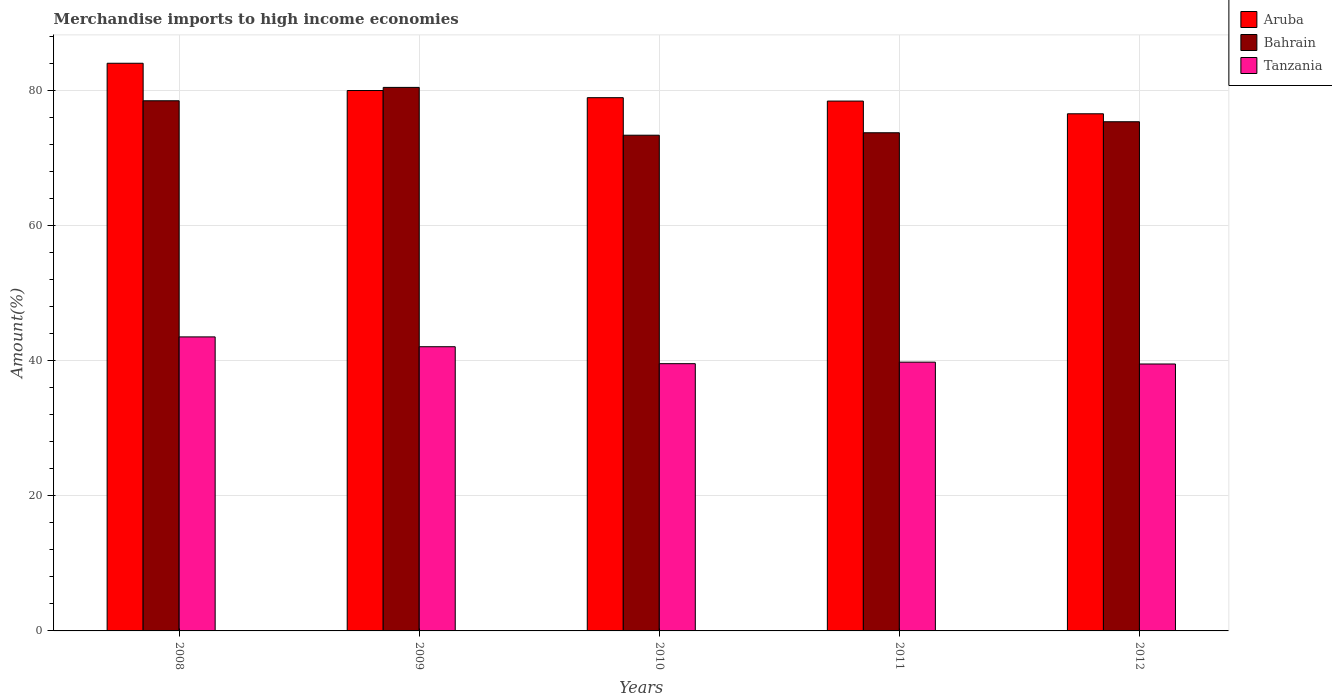How many different coloured bars are there?
Provide a short and direct response. 3. How many groups of bars are there?
Your response must be concise. 5. Are the number of bars on each tick of the X-axis equal?
Give a very brief answer. Yes. What is the label of the 5th group of bars from the left?
Give a very brief answer. 2012. What is the percentage of amount earned from merchandise imports in Aruba in 2011?
Your response must be concise. 78.49. Across all years, what is the maximum percentage of amount earned from merchandise imports in Tanzania?
Ensure brevity in your answer.  43.55. Across all years, what is the minimum percentage of amount earned from merchandise imports in Aruba?
Your answer should be very brief. 76.6. In which year was the percentage of amount earned from merchandise imports in Bahrain maximum?
Keep it short and to the point. 2009. What is the total percentage of amount earned from merchandise imports in Aruba in the graph?
Offer a very short reply. 398.22. What is the difference between the percentage of amount earned from merchandise imports in Tanzania in 2008 and that in 2009?
Provide a succinct answer. 1.45. What is the difference between the percentage of amount earned from merchandise imports in Aruba in 2010 and the percentage of amount earned from merchandise imports in Bahrain in 2012?
Your answer should be compact. 3.57. What is the average percentage of amount earned from merchandise imports in Tanzania per year?
Offer a very short reply. 40.92. In the year 2010, what is the difference between the percentage of amount earned from merchandise imports in Aruba and percentage of amount earned from merchandise imports in Bahrain?
Keep it short and to the point. 5.56. What is the ratio of the percentage of amount earned from merchandise imports in Aruba in 2009 to that in 2012?
Provide a short and direct response. 1.04. Is the percentage of amount earned from merchandise imports in Tanzania in 2010 less than that in 2012?
Provide a succinct answer. No. Is the difference between the percentage of amount earned from merchandise imports in Aruba in 2009 and 2011 greater than the difference between the percentage of amount earned from merchandise imports in Bahrain in 2009 and 2011?
Provide a short and direct response. No. What is the difference between the highest and the second highest percentage of amount earned from merchandise imports in Aruba?
Provide a succinct answer. 4.04. What is the difference between the highest and the lowest percentage of amount earned from merchandise imports in Tanzania?
Your response must be concise. 4.01. In how many years, is the percentage of amount earned from merchandise imports in Aruba greater than the average percentage of amount earned from merchandise imports in Aruba taken over all years?
Make the answer very short. 2. Is the sum of the percentage of amount earned from merchandise imports in Aruba in 2009 and 2012 greater than the maximum percentage of amount earned from merchandise imports in Bahrain across all years?
Your answer should be compact. Yes. What does the 3rd bar from the left in 2011 represents?
Make the answer very short. Tanzania. What does the 3rd bar from the right in 2009 represents?
Give a very brief answer. Aruba. Does the graph contain any zero values?
Provide a short and direct response. No. How are the legend labels stacked?
Offer a very short reply. Vertical. What is the title of the graph?
Offer a terse response. Merchandise imports to high income economies. Does "Moldova" appear as one of the legend labels in the graph?
Ensure brevity in your answer.  No. What is the label or title of the X-axis?
Make the answer very short. Years. What is the label or title of the Y-axis?
Provide a succinct answer. Amount(%). What is the Amount(%) in Aruba in 2008?
Your answer should be compact. 84.09. What is the Amount(%) in Bahrain in 2008?
Provide a succinct answer. 78.53. What is the Amount(%) of Tanzania in 2008?
Offer a very short reply. 43.55. What is the Amount(%) in Aruba in 2009?
Make the answer very short. 80.05. What is the Amount(%) in Bahrain in 2009?
Your answer should be compact. 80.51. What is the Amount(%) in Tanzania in 2009?
Your answer should be very brief. 42.1. What is the Amount(%) in Aruba in 2010?
Keep it short and to the point. 78.99. What is the Amount(%) in Bahrain in 2010?
Ensure brevity in your answer.  73.43. What is the Amount(%) of Tanzania in 2010?
Keep it short and to the point. 39.59. What is the Amount(%) of Aruba in 2011?
Give a very brief answer. 78.49. What is the Amount(%) in Bahrain in 2011?
Your answer should be compact. 73.79. What is the Amount(%) of Tanzania in 2011?
Make the answer very short. 39.81. What is the Amount(%) in Aruba in 2012?
Keep it short and to the point. 76.6. What is the Amount(%) of Bahrain in 2012?
Offer a very short reply. 75.42. What is the Amount(%) of Tanzania in 2012?
Provide a short and direct response. 39.54. Across all years, what is the maximum Amount(%) of Aruba?
Make the answer very short. 84.09. Across all years, what is the maximum Amount(%) of Bahrain?
Give a very brief answer. 80.51. Across all years, what is the maximum Amount(%) in Tanzania?
Offer a terse response. 43.55. Across all years, what is the minimum Amount(%) of Aruba?
Give a very brief answer. 76.6. Across all years, what is the minimum Amount(%) in Bahrain?
Offer a very short reply. 73.43. Across all years, what is the minimum Amount(%) of Tanzania?
Offer a very short reply. 39.54. What is the total Amount(%) of Aruba in the graph?
Provide a short and direct response. 398.22. What is the total Amount(%) in Bahrain in the graph?
Keep it short and to the point. 381.69. What is the total Amount(%) in Tanzania in the graph?
Keep it short and to the point. 204.59. What is the difference between the Amount(%) of Aruba in 2008 and that in 2009?
Provide a succinct answer. 4.04. What is the difference between the Amount(%) of Bahrain in 2008 and that in 2009?
Ensure brevity in your answer.  -1.98. What is the difference between the Amount(%) in Tanzania in 2008 and that in 2009?
Keep it short and to the point. 1.45. What is the difference between the Amount(%) in Aruba in 2008 and that in 2010?
Provide a short and direct response. 5.1. What is the difference between the Amount(%) in Bahrain in 2008 and that in 2010?
Your response must be concise. 5.1. What is the difference between the Amount(%) in Tanzania in 2008 and that in 2010?
Make the answer very short. 3.97. What is the difference between the Amount(%) of Aruba in 2008 and that in 2011?
Make the answer very short. 5.6. What is the difference between the Amount(%) in Bahrain in 2008 and that in 2011?
Your answer should be very brief. 4.74. What is the difference between the Amount(%) in Tanzania in 2008 and that in 2011?
Your answer should be compact. 3.74. What is the difference between the Amount(%) of Aruba in 2008 and that in 2012?
Your answer should be compact. 7.48. What is the difference between the Amount(%) of Bahrain in 2008 and that in 2012?
Ensure brevity in your answer.  3.11. What is the difference between the Amount(%) in Tanzania in 2008 and that in 2012?
Offer a very short reply. 4.01. What is the difference between the Amount(%) of Aruba in 2009 and that in 2010?
Provide a short and direct response. 1.06. What is the difference between the Amount(%) in Bahrain in 2009 and that in 2010?
Your answer should be very brief. 7.08. What is the difference between the Amount(%) in Tanzania in 2009 and that in 2010?
Provide a succinct answer. 2.51. What is the difference between the Amount(%) of Aruba in 2009 and that in 2011?
Provide a succinct answer. 1.56. What is the difference between the Amount(%) in Bahrain in 2009 and that in 2011?
Offer a terse response. 6.72. What is the difference between the Amount(%) in Tanzania in 2009 and that in 2011?
Provide a short and direct response. 2.29. What is the difference between the Amount(%) of Aruba in 2009 and that in 2012?
Ensure brevity in your answer.  3.45. What is the difference between the Amount(%) in Bahrain in 2009 and that in 2012?
Your answer should be very brief. 5.09. What is the difference between the Amount(%) of Tanzania in 2009 and that in 2012?
Offer a very short reply. 2.56. What is the difference between the Amount(%) in Aruba in 2010 and that in 2011?
Your answer should be very brief. 0.5. What is the difference between the Amount(%) of Bahrain in 2010 and that in 2011?
Offer a very short reply. -0.36. What is the difference between the Amount(%) of Tanzania in 2010 and that in 2011?
Your answer should be compact. -0.23. What is the difference between the Amount(%) in Aruba in 2010 and that in 2012?
Provide a succinct answer. 2.39. What is the difference between the Amount(%) in Bahrain in 2010 and that in 2012?
Provide a short and direct response. -1.99. What is the difference between the Amount(%) in Tanzania in 2010 and that in 2012?
Your answer should be very brief. 0.05. What is the difference between the Amount(%) of Aruba in 2011 and that in 2012?
Make the answer very short. 1.88. What is the difference between the Amount(%) in Bahrain in 2011 and that in 2012?
Give a very brief answer. -1.63. What is the difference between the Amount(%) of Tanzania in 2011 and that in 2012?
Your answer should be compact. 0.27. What is the difference between the Amount(%) in Aruba in 2008 and the Amount(%) in Bahrain in 2009?
Your answer should be very brief. 3.57. What is the difference between the Amount(%) of Aruba in 2008 and the Amount(%) of Tanzania in 2009?
Make the answer very short. 41.99. What is the difference between the Amount(%) in Bahrain in 2008 and the Amount(%) in Tanzania in 2009?
Your answer should be compact. 36.43. What is the difference between the Amount(%) in Aruba in 2008 and the Amount(%) in Bahrain in 2010?
Keep it short and to the point. 10.66. What is the difference between the Amount(%) of Aruba in 2008 and the Amount(%) of Tanzania in 2010?
Your answer should be compact. 44.5. What is the difference between the Amount(%) of Bahrain in 2008 and the Amount(%) of Tanzania in 2010?
Provide a succinct answer. 38.94. What is the difference between the Amount(%) of Aruba in 2008 and the Amount(%) of Bahrain in 2011?
Keep it short and to the point. 10.29. What is the difference between the Amount(%) in Aruba in 2008 and the Amount(%) in Tanzania in 2011?
Your answer should be very brief. 44.27. What is the difference between the Amount(%) of Bahrain in 2008 and the Amount(%) of Tanzania in 2011?
Your response must be concise. 38.72. What is the difference between the Amount(%) in Aruba in 2008 and the Amount(%) in Bahrain in 2012?
Offer a terse response. 8.66. What is the difference between the Amount(%) in Aruba in 2008 and the Amount(%) in Tanzania in 2012?
Provide a succinct answer. 44.55. What is the difference between the Amount(%) in Bahrain in 2008 and the Amount(%) in Tanzania in 2012?
Your answer should be compact. 38.99. What is the difference between the Amount(%) of Aruba in 2009 and the Amount(%) of Bahrain in 2010?
Your answer should be compact. 6.62. What is the difference between the Amount(%) of Aruba in 2009 and the Amount(%) of Tanzania in 2010?
Provide a succinct answer. 40.46. What is the difference between the Amount(%) of Bahrain in 2009 and the Amount(%) of Tanzania in 2010?
Give a very brief answer. 40.93. What is the difference between the Amount(%) in Aruba in 2009 and the Amount(%) in Bahrain in 2011?
Provide a succinct answer. 6.26. What is the difference between the Amount(%) in Aruba in 2009 and the Amount(%) in Tanzania in 2011?
Your response must be concise. 40.24. What is the difference between the Amount(%) of Bahrain in 2009 and the Amount(%) of Tanzania in 2011?
Provide a short and direct response. 40.7. What is the difference between the Amount(%) of Aruba in 2009 and the Amount(%) of Bahrain in 2012?
Ensure brevity in your answer.  4.63. What is the difference between the Amount(%) in Aruba in 2009 and the Amount(%) in Tanzania in 2012?
Ensure brevity in your answer.  40.51. What is the difference between the Amount(%) of Bahrain in 2009 and the Amount(%) of Tanzania in 2012?
Your answer should be very brief. 40.97. What is the difference between the Amount(%) of Aruba in 2010 and the Amount(%) of Bahrain in 2011?
Offer a terse response. 5.2. What is the difference between the Amount(%) of Aruba in 2010 and the Amount(%) of Tanzania in 2011?
Keep it short and to the point. 39.18. What is the difference between the Amount(%) of Bahrain in 2010 and the Amount(%) of Tanzania in 2011?
Provide a short and direct response. 33.62. What is the difference between the Amount(%) of Aruba in 2010 and the Amount(%) of Bahrain in 2012?
Your response must be concise. 3.57. What is the difference between the Amount(%) of Aruba in 2010 and the Amount(%) of Tanzania in 2012?
Offer a terse response. 39.45. What is the difference between the Amount(%) in Bahrain in 2010 and the Amount(%) in Tanzania in 2012?
Your response must be concise. 33.89. What is the difference between the Amount(%) in Aruba in 2011 and the Amount(%) in Bahrain in 2012?
Offer a very short reply. 3.06. What is the difference between the Amount(%) in Aruba in 2011 and the Amount(%) in Tanzania in 2012?
Your response must be concise. 38.95. What is the difference between the Amount(%) of Bahrain in 2011 and the Amount(%) of Tanzania in 2012?
Your answer should be very brief. 34.25. What is the average Amount(%) in Aruba per year?
Your answer should be very brief. 79.64. What is the average Amount(%) in Bahrain per year?
Provide a succinct answer. 76.34. What is the average Amount(%) in Tanzania per year?
Make the answer very short. 40.92. In the year 2008, what is the difference between the Amount(%) of Aruba and Amount(%) of Bahrain?
Provide a short and direct response. 5.56. In the year 2008, what is the difference between the Amount(%) in Aruba and Amount(%) in Tanzania?
Offer a terse response. 40.53. In the year 2008, what is the difference between the Amount(%) in Bahrain and Amount(%) in Tanzania?
Give a very brief answer. 34.98. In the year 2009, what is the difference between the Amount(%) in Aruba and Amount(%) in Bahrain?
Offer a very short reply. -0.46. In the year 2009, what is the difference between the Amount(%) of Aruba and Amount(%) of Tanzania?
Keep it short and to the point. 37.95. In the year 2009, what is the difference between the Amount(%) of Bahrain and Amount(%) of Tanzania?
Offer a very short reply. 38.41. In the year 2010, what is the difference between the Amount(%) in Aruba and Amount(%) in Bahrain?
Provide a succinct answer. 5.56. In the year 2010, what is the difference between the Amount(%) of Aruba and Amount(%) of Tanzania?
Offer a terse response. 39.4. In the year 2010, what is the difference between the Amount(%) of Bahrain and Amount(%) of Tanzania?
Your response must be concise. 33.84. In the year 2011, what is the difference between the Amount(%) of Aruba and Amount(%) of Bahrain?
Provide a short and direct response. 4.69. In the year 2011, what is the difference between the Amount(%) of Aruba and Amount(%) of Tanzania?
Ensure brevity in your answer.  38.67. In the year 2011, what is the difference between the Amount(%) of Bahrain and Amount(%) of Tanzania?
Make the answer very short. 33.98. In the year 2012, what is the difference between the Amount(%) in Aruba and Amount(%) in Bahrain?
Your answer should be compact. 1.18. In the year 2012, what is the difference between the Amount(%) of Aruba and Amount(%) of Tanzania?
Your response must be concise. 37.06. In the year 2012, what is the difference between the Amount(%) in Bahrain and Amount(%) in Tanzania?
Give a very brief answer. 35.88. What is the ratio of the Amount(%) in Aruba in 2008 to that in 2009?
Your answer should be compact. 1.05. What is the ratio of the Amount(%) of Bahrain in 2008 to that in 2009?
Provide a succinct answer. 0.98. What is the ratio of the Amount(%) in Tanzania in 2008 to that in 2009?
Ensure brevity in your answer.  1.03. What is the ratio of the Amount(%) in Aruba in 2008 to that in 2010?
Provide a short and direct response. 1.06. What is the ratio of the Amount(%) in Bahrain in 2008 to that in 2010?
Give a very brief answer. 1.07. What is the ratio of the Amount(%) of Tanzania in 2008 to that in 2010?
Your answer should be very brief. 1.1. What is the ratio of the Amount(%) of Aruba in 2008 to that in 2011?
Your response must be concise. 1.07. What is the ratio of the Amount(%) of Bahrain in 2008 to that in 2011?
Your answer should be very brief. 1.06. What is the ratio of the Amount(%) of Tanzania in 2008 to that in 2011?
Provide a short and direct response. 1.09. What is the ratio of the Amount(%) of Aruba in 2008 to that in 2012?
Keep it short and to the point. 1.1. What is the ratio of the Amount(%) in Bahrain in 2008 to that in 2012?
Your answer should be compact. 1.04. What is the ratio of the Amount(%) of Tanzania in 2008 to that in 2012?
Offer a terse response. 1.1. What is the ratio of the Amount(%) in Aruba in 2009 to that in 2010?
Your answer should be very brief. 1.01. What is the ratio of the Amount(%) of Bahrain in 2009 to that in 2010?
Make the answer very short. 1.1. What is the ratio of the Amount(%) of Tanzania in 2009 to that in 2010?
Give a very brief answer. 1.06. What is the ratio of the Amount(%) in Aruba in 2009 to that in 2011?
Offer a very short reply. 1.02. What is the ratio of the Amount(%) of Bahrain in 2009 to that in 2011?
Your answer should be very brief. 1.09. What is the ratio of the Amount(%) of Tanzania in 2009 to that in 2011?
Provide a short and direct response. 1.06. What is the ratio of the Amount(%) of Aruba in 2009 to that in 2012?
Offer a terse response. 1.04. What is the ratio of the Amount(%) of Bahrain in 2009 to that in 2012?
Provide a short and direct response. 1.07. What is the ratio of the Amount(%) in Tanzania in 2009 to that in 2012?
Provide a succinct answer. 1.06. What is the ratio of the Amount(%) in Aruba in 2010 to that in 2011?
Your response must be concise. 1.01. What is the ratio of the Amount(%) of Aruba in 2010 to that in 2012?
Keep it short and to the point. 1.03. What is the ratio of the Amount(%) in Bahrain in 2010 to that in 2012?
Give a very brief answer. 0.97. What is the ratio of the Amount(%) of Aruba in 2011 to that in 2012?
Provide a succinct answer. 1.02. What is the ratio of the Amount(%) in Bahrain in 2011 to that in 2012?
Ensure brevity in your answer.  0.98. What is the ratio of the Amount(%) of Tanzania in 2011 to that in 2012?
Keep it short and to the point. 1.01. What is the difference between the highest and the second highest Amount(%) of Aruba?
Make the answer very short. 4.04. What is the difference between the highest and the second highest Amount(%) in Bahrain?
Make the answer very short. 1.98. What is the difference between the highest and the second highest Amount(%) in Tanzania?
Keep it short and to the point. 1.45. What is the difference between the highest and the lowest Amount(%) of Aruba?
Your answer should be very brief. 7.48. What is the difference between the highest and the lowest Amount(%) in Bahrain?
Provide a short and direct response. 7.08. What is the difference between the highest and the lowest Amount(%) of Tanzania?
Ensure brevity in your answer.  4.01. 